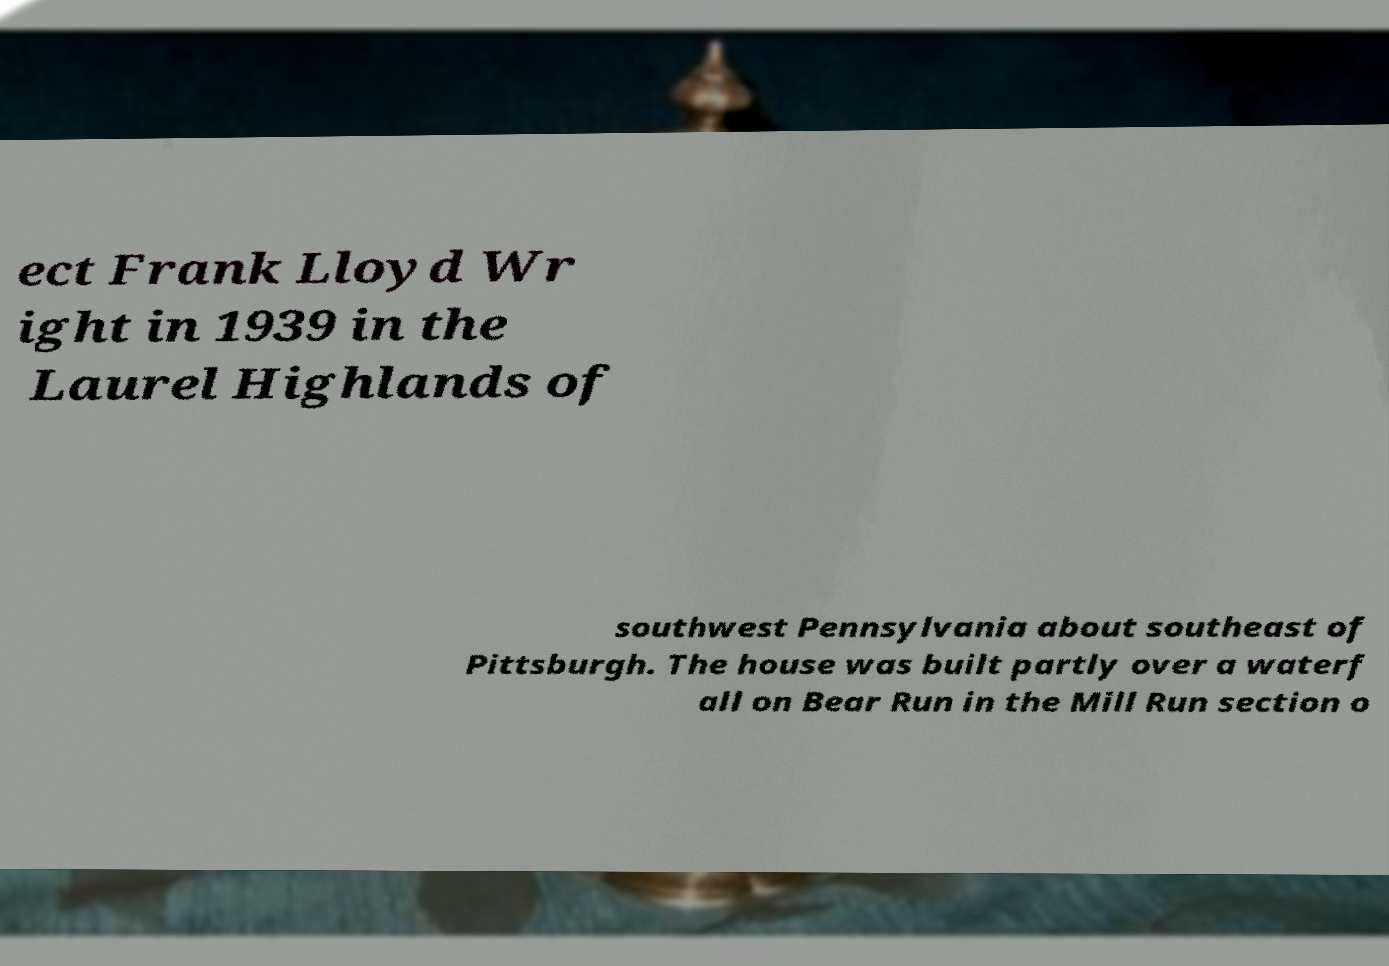I need the written content from this picture converted into text. Can you do that? ect Frank Lloyd Wr ight in 1939 in the Laurel Highlands of southwest Pennsylvania about southeast of Pittsburgh. The house was built partly over a waterf all on Bear Run in the Mill Run section o 